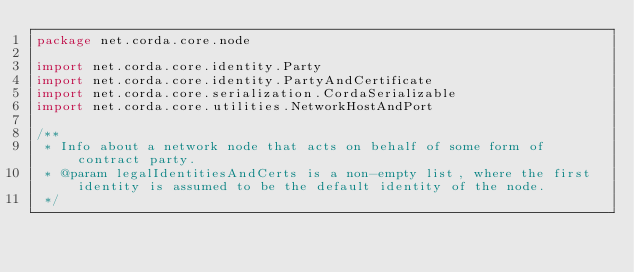Convert code to text. <code><loc_0><loc_0><loc_500><loc_500><_Kotlin_>package net.corda.core.node

import net.corda.core.identity.Party
import net.corda.core.identity.PartyAndCertificate
import net.corda.core.serialization.CordaSerializable
import net.corda.core.utilities.NetworkHostAndPort

/**
 * Info about a network node that acts on behalf of some form of contract party.
 * @param legalIdentitiesAndCerts is a non-empty list, where the first identity is assumed to be the default identity of the node.
 */</code> 